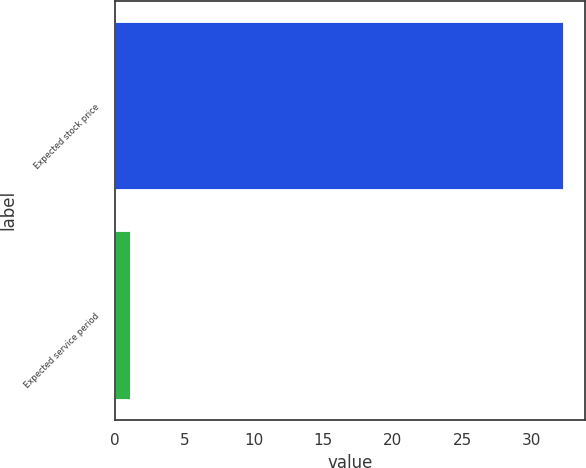Convert chart. <chart><loc_0><loc_0><loc_500><loc_500><bar_chart><fcel>Expected stock price<fcel>Expected service period<nl><fcel>32.2<fcel>1.1<nl></chart> 